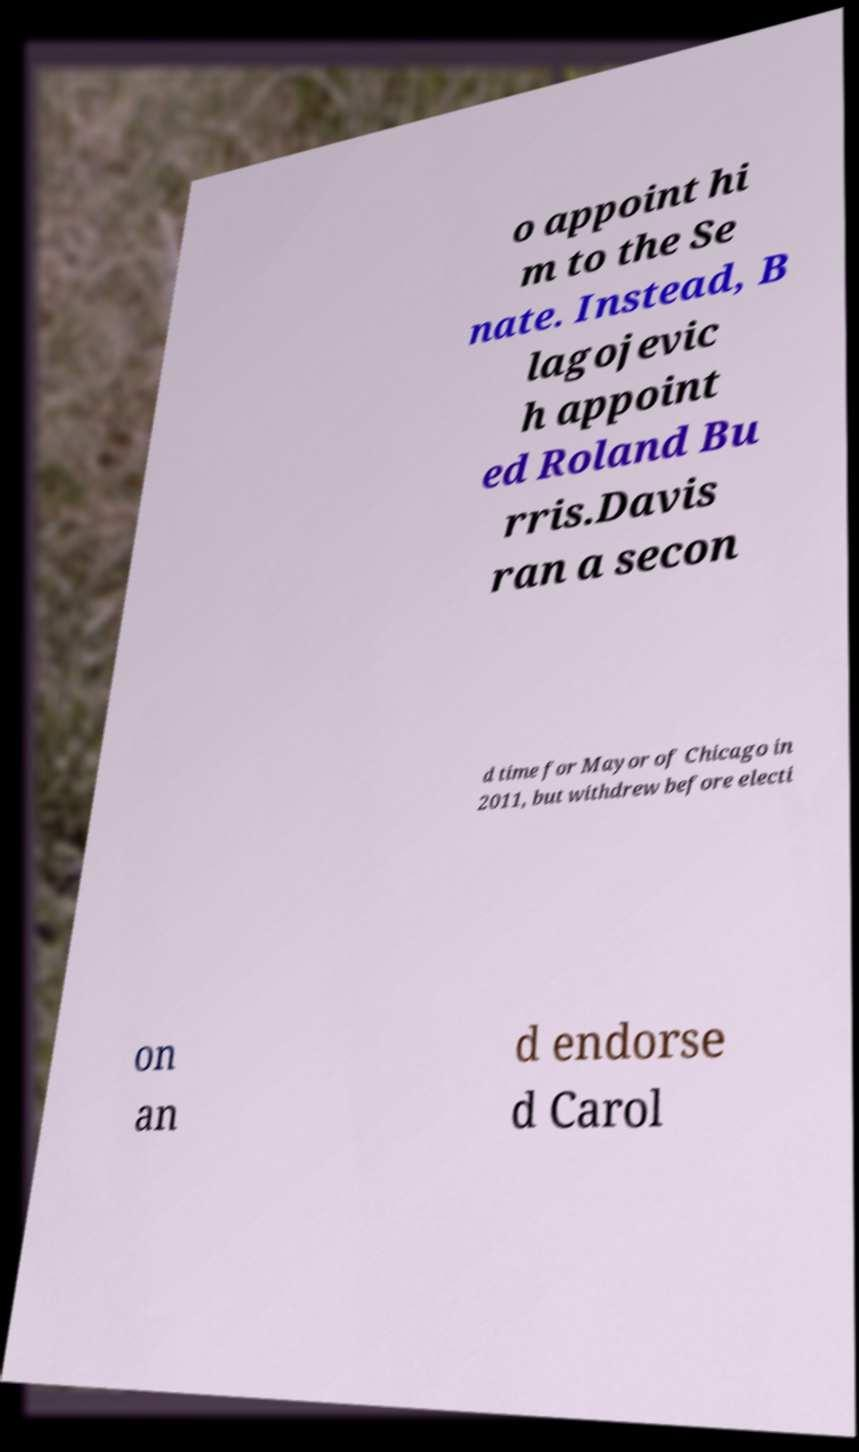There's text embedded in this image that I need extracted. Can you transcribe it verbatim? o appoint hi m to the Se nate. Instead, B lagojevic h appoint ed Roland Bu rris.Davis ran a secon d time for Mayor of Chicago in 2011, but withdrew before electi on an d endorse d Carol 